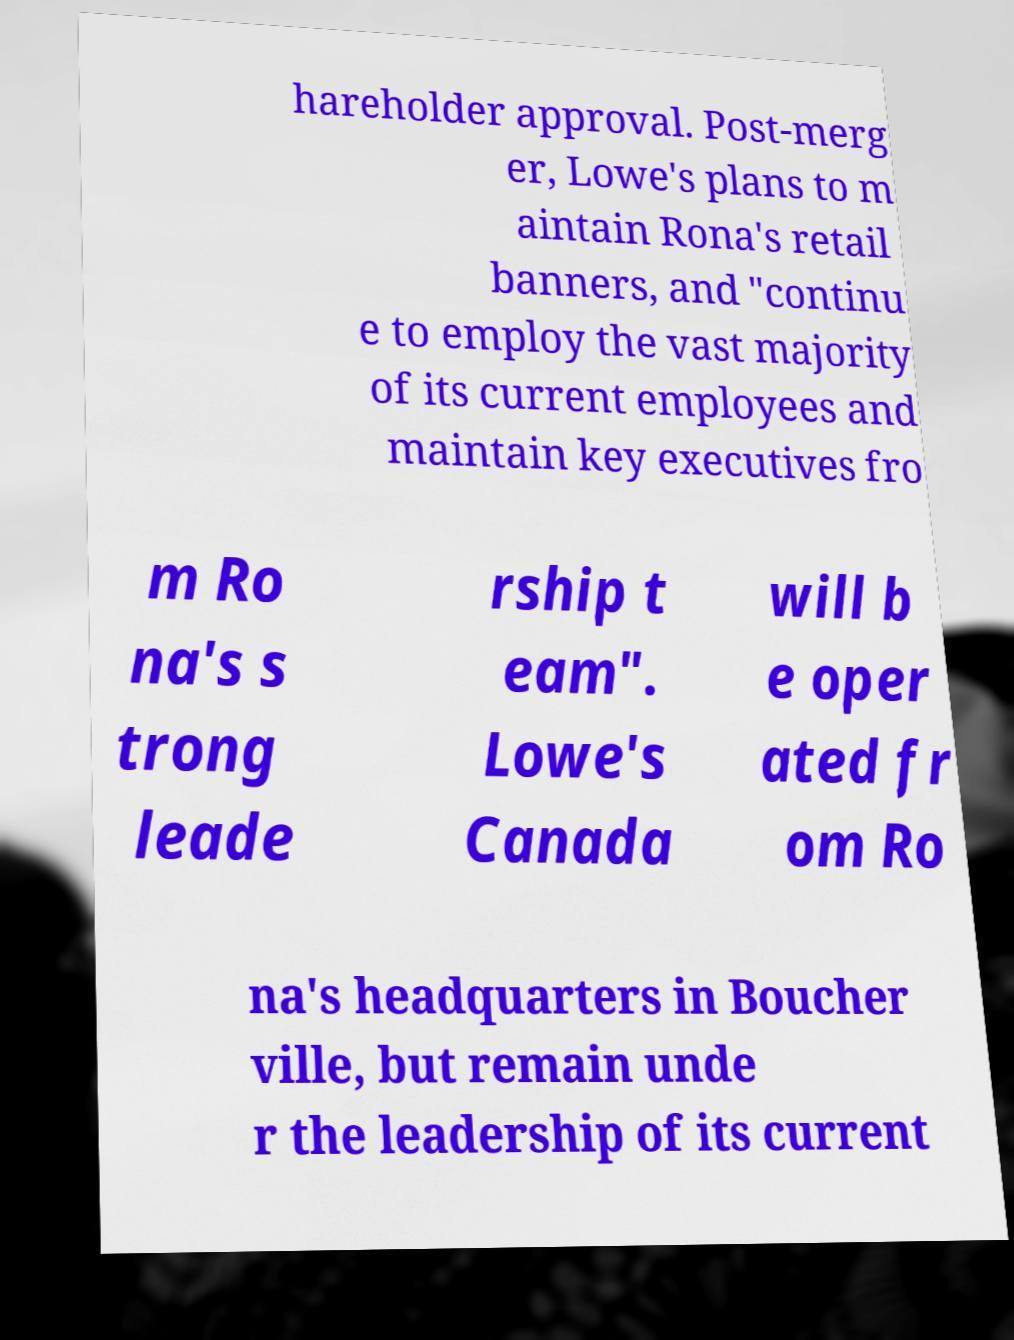I need the written content from this picture converted into text. Can you do that? hareholder approval. Post-merg er, Lowe's plans to m aintain Rona's retail banners, and "continu e to employ the vast majority of its current employees and maintain key executives fro m Ro na's s trong leade rship t eam". Lowe's Canada will b e oper ated fr om Ro na's headquarters in Boucher ville, but remain unde r the leadership of its current 